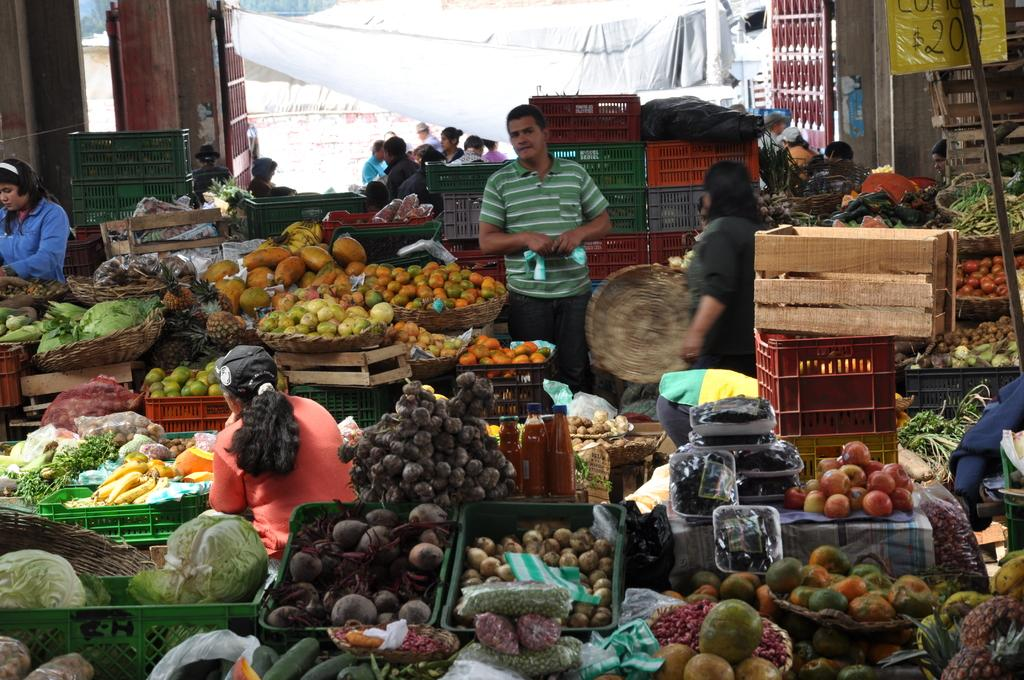What type of location is depicted in the image? The image shows an inside view of a market. What types of food items can be seen in the market? There are fruits and vegetables in the market. What kind of objects are made of wood in the market? There are wooden objects in the market. How are the items stored or displayed in the market? There are boxes in the market that are used for storage or display in the market. What is the entrance to the market? There is a gate in the market. Are there any people present in the market? Yes, there are people standing in the market. What type of tomatoes are being used for the recess activity in the image? There is no recess activity or tomatoes present in the image. What type of operation is being performed on the wooden objects in the image? There is no operation being performed on the wooden objects in the image. 